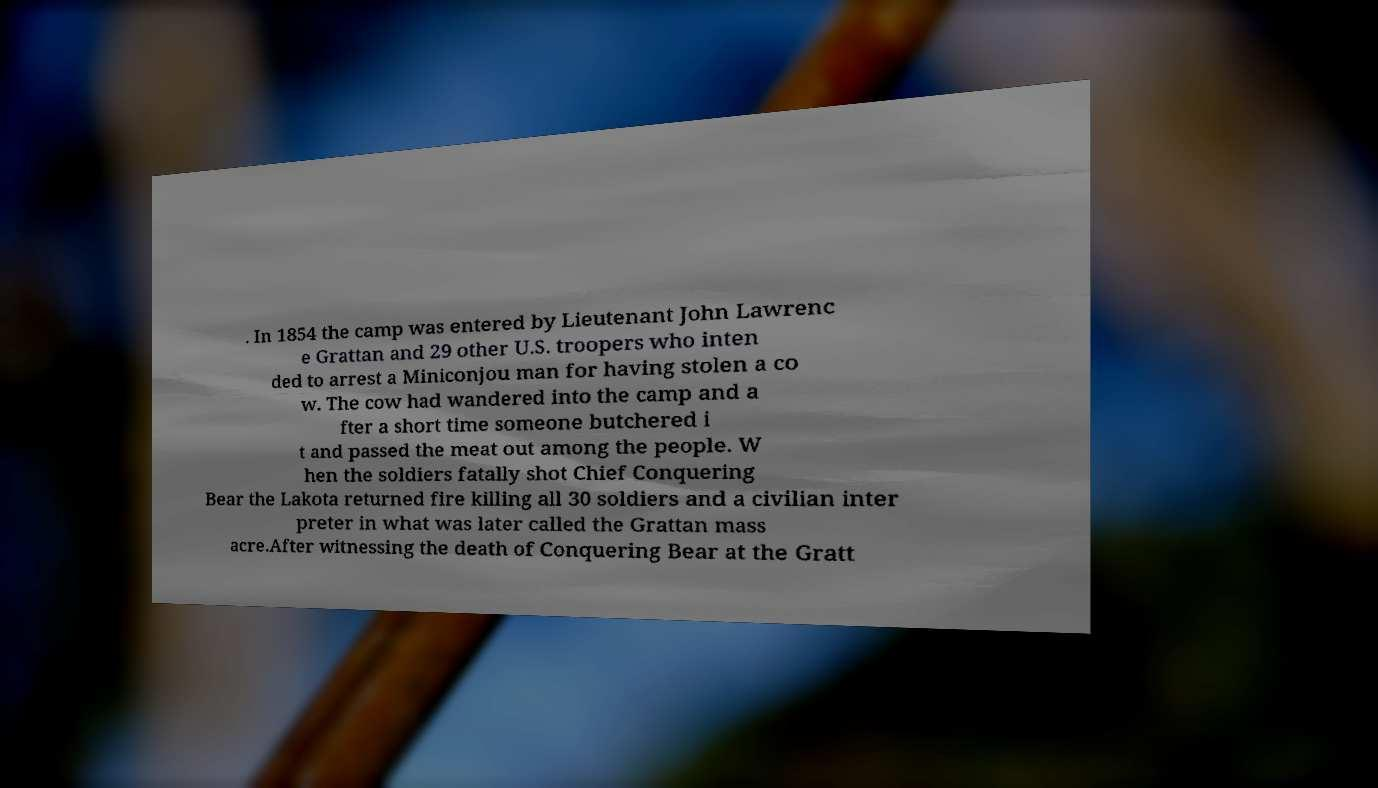What messages or text are displayed in this image? I need them in a readable, typed format. . In 1854 the camp was entered by Lieutenant John Lawrenc e Grattan and 29 other U.S. troopers who inten ded to arrest a Miniconjou man for having stolen a co w. The cow had wandered into the camp and a fter a short time someone butchered i t and passed the meat out among the people. W hen the soldiers fatally shot Chief Conquering Bear the Lakota returned fire killing all 30 soldiers and a civilian inter preter in what was later called the Grattan mass acre.After witnessing the death of Conquering Bear at the Gratt 